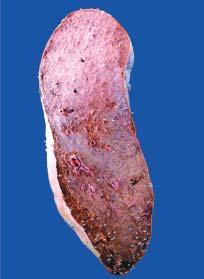what is heavy and enlarged in size?
Answer the question using a single word or phrase. Spleen 